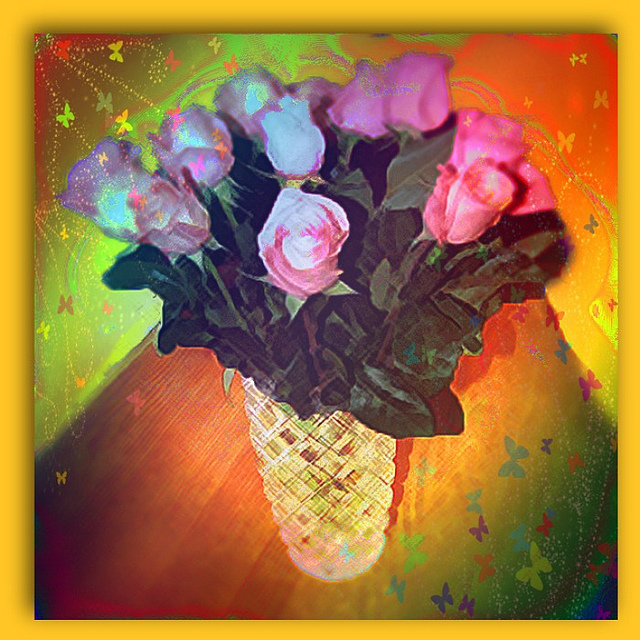What emotions does this image evoke? The image evokes feelings of happiness and positivity, due to its bright and surreal color palette. The whimsical touches, including the butterflies and sparkling elements, contribute to a sense of wonder and enchantment. Overall, it creates an uplifting and joyous mood. 